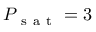Convert formula to latex. <formula><loc_0><loc_0><loc_500><loc_500>P _ { s a t } = 3</formula> 